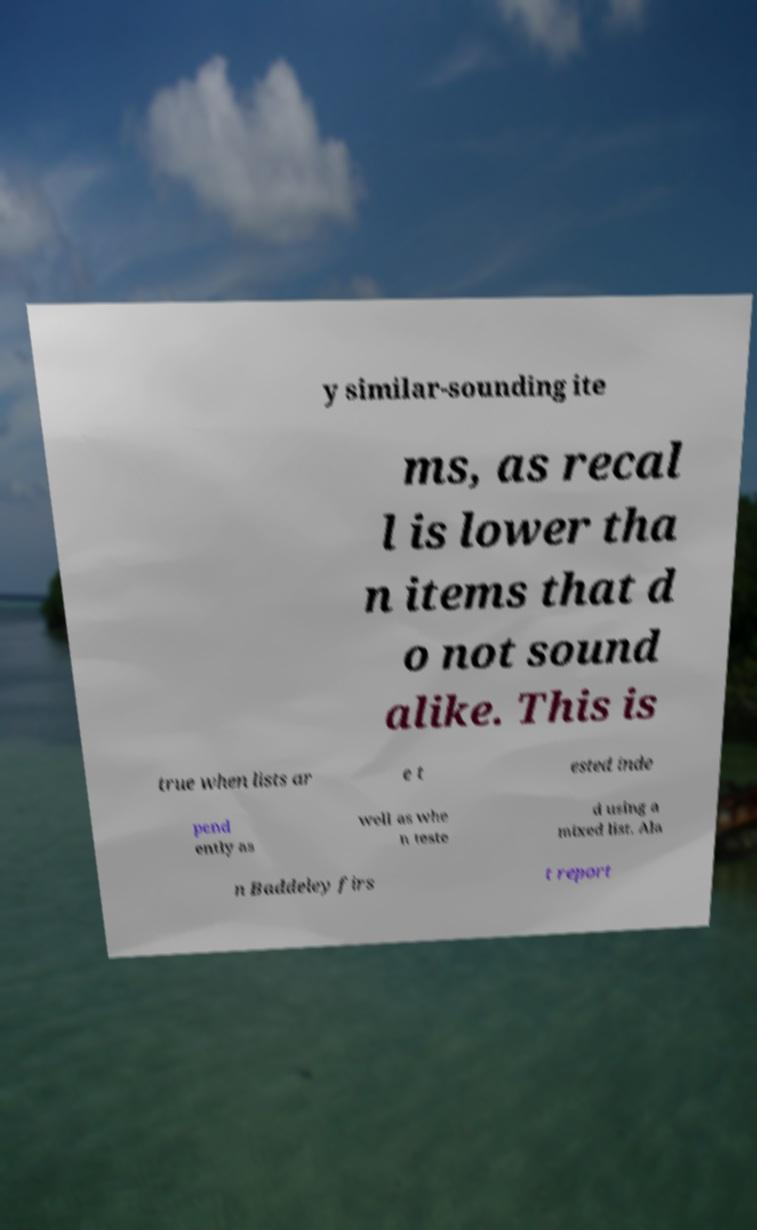Can you accurately transcribe the text from the provided image for me? y similar-sounding ite ms, as recal l is lower tha n items that d o not sound alike. This is true when lists ar e t ested inde pend ently as well as whe n teste d using a mixed list. Ala n Baddeley firs t report 